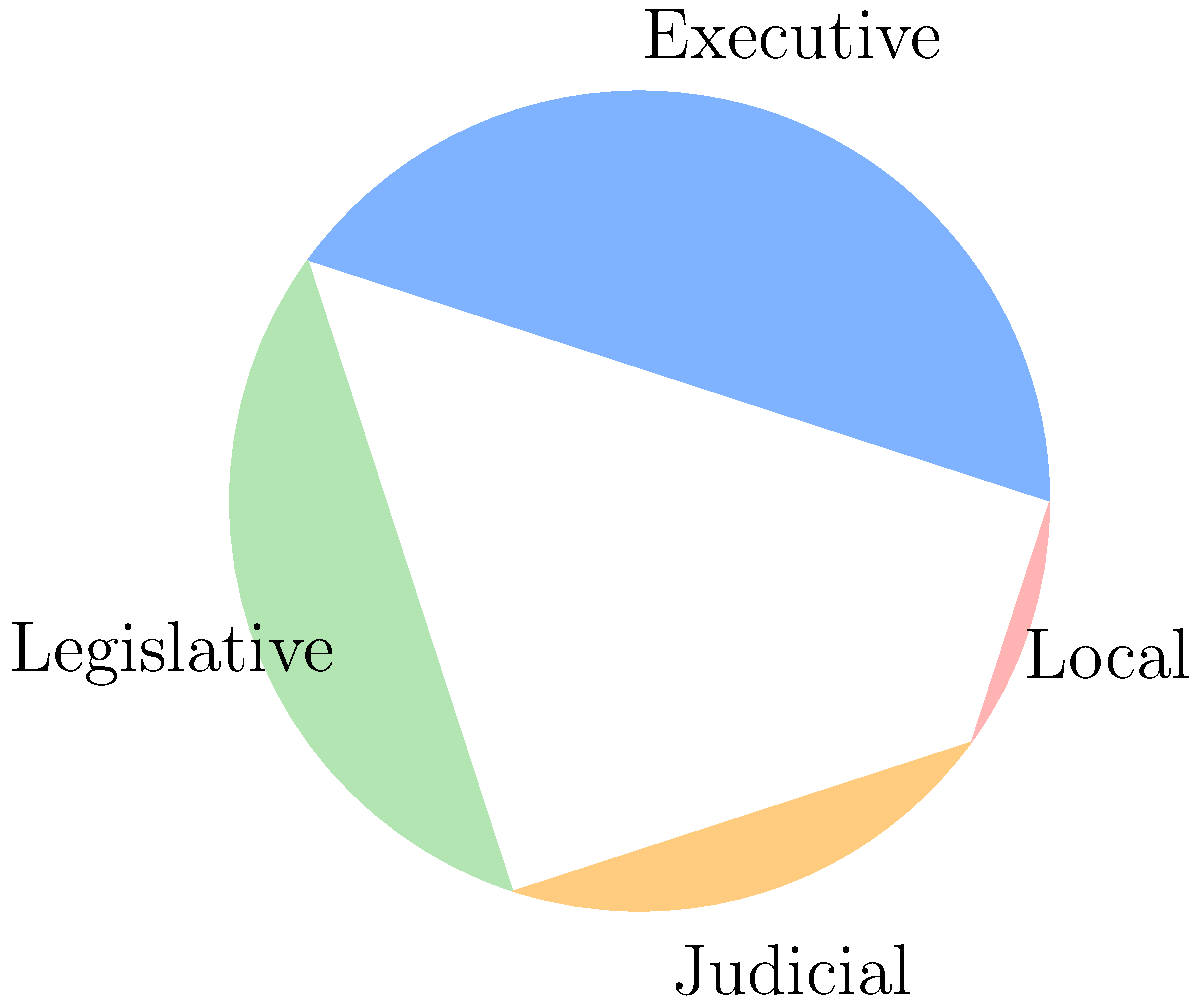In the pie chart depicting the distribution of power in a democratic system, which branch of government holds the largest share, and how does this distribution reflect the principle of checks and balances? To answer this question, let's analyze the pie chart step-by-step:

1. Identify the branches of government:
   - Executive: 40%
   - Legislative: 30%
   - Judicial: 20%
   - Local: 10%

2. Determine the largest share:
   The Executive branch holds the largest share at 40%.

3. Analyze the distribution in relation to checks and balances:
   a) The Executive (40%) and Legislative (30%) branches have the two largest shares, reflecting their significant roles in policy-making and implementation.
   b) The Judicial branch (20%) has a smaller but substantial share, indicating its important role in interpreting laws and maintaining constitutional order.
   c) Local government (10%) has the smallest share, representing decentralized power.

4. Reflect on checks and balances:
   - The distribution shows no single branch holding an overwhelming majority of power.
   - The Executive and Legislative branches have similar sizes, allowing for effective checks on each other's power.
   - The Judicial branch's significant share enables it to act as a check on both the Executive and Legislative branches.
   - The presence of Local government power demonstrates a vertical separation of powers, further enhancing the system of checks and balances.

This distribution reflects the principle of checks and balances by ensuring that power is distributed among different branches, preventing any single entity from becoming too powerful and allowing each branch to oversee and limit the actions of the others.
Answer: Executive branch (40%); distribution prevents concentration of power, enabling mutual oversight. 